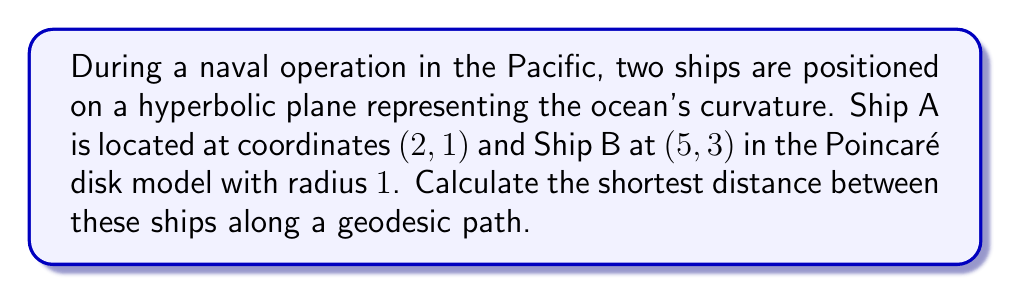Teach me how to tackle this problem. To solve this problem, we'll use the formula for the distance between two points in the Poincaré disk model of hyperbolic geometry. The steps are as follows:

1) The distance formula in the Poincaré disk model is:

   $$d = \text{arcosh}\left(1 + \frac{2|z_2 - z_1|^2}{(1-|z_1|^2)(1-|z_2|^2)}\right)$$

   where $z_1$ and $z_2$ are complex numbers representing the points.

2) Convert the given coordinates to complex numbers:
   $z_1 = 2 + i$ and $z_2 = 5 + 3i$

3) Calculate $|z_1|^2$ and $|z_2|^2$:
   $|z_1|^2 = 2^2 + 1^2 = 5$
   $|z_2|^2 = 5^2 + 3^2 = 34$

4) Calculate $|z_2 - z_1|^2$:
   $|z_2 - z_1|^2 = |3 + 2i|^2 = 3^2 + 2^2 = 13$

5) Substitute these values into the distance formula:

   $$d = \text{arcosh}\left(1 + \frac{2(13)}{(1-5)(1-34)}\right)$$

6) Simplify:
   $$d = \text{arcosh}\left(1 + \frac{26}{(-4)(-33)}\right) = \text{arcosh}\left(1 + \frac{26}{132}\right)$$

7) Calculate the final result:
   $$d = \text{arcosh}(1.1969...) \approx 0.6158$$

This distance is in hyperbolic units. To convert to nautical miles, you would need to multiply by the radius of curvature of the hyperbolic plane, which depends on the specific model of the Earth's curvature being used.
Answer: $\text{arcosh}(1 + \frac{13}{66}) \approx 0.6158$ hyperbolic units 